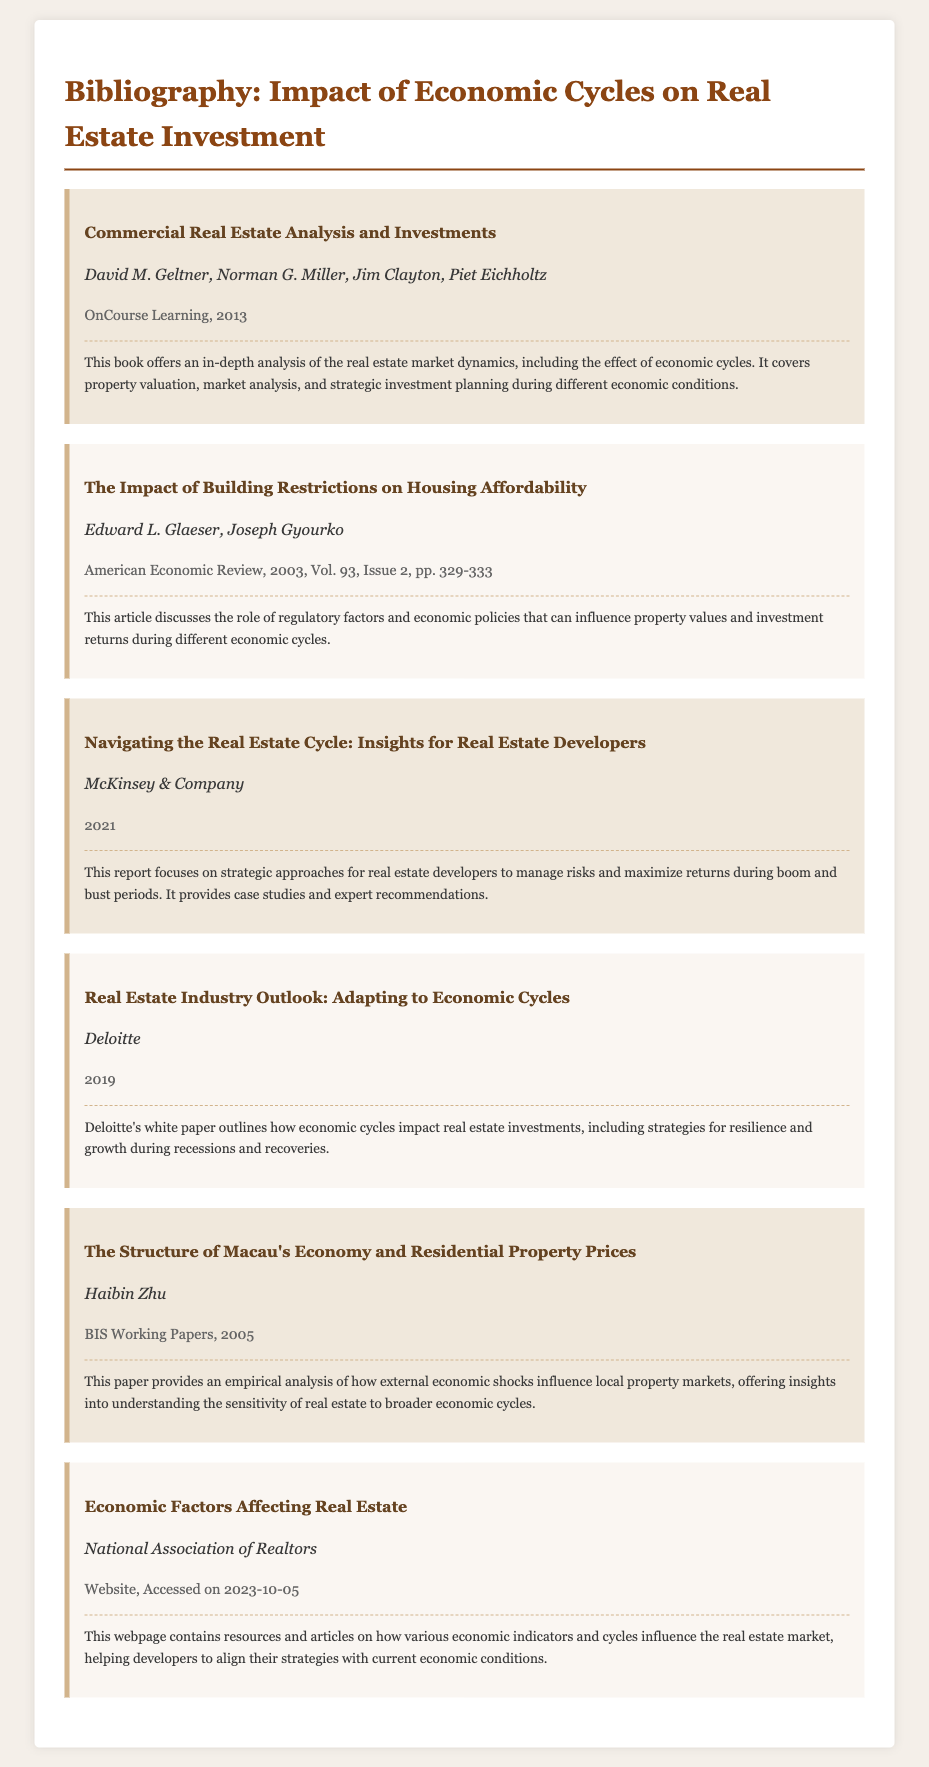what is the title of the first item in the bibliography? The title of the first item in the bibliography is found in the part of the document that lists the bibliographic entries.
Answer: Commercial Real Estate Analysis and Investments who are the authors of "Navigating the Real Estate Cycle: Insights for Real Estate Developers"? The authors of the specified report are listed right under the title in its respective section.
Answer: McKinsey & Company in which year was the article "The Impact of Building Restrictions on Housing Affordability" published? The publication year of this article can be found in the publication information section of the bibliography entry.
Answer: 2003 what type of document is "Economic Factors Affecting Real Estate"? The type of document for this entry is indicated in the publication information portion of the bibliography.
Answer: Website how many bibliographic items are listed in the document? The total number of bibliographic items is counted from each entry in the rendered document.
Answer: Six what is the main focus of Deloitte's white paper? The main focus can be summarized by looking at the description provided for this particular item in the bibliography.
Answer: Economic cycles impact real estate investments which organization produced the report "Navigating the Real Estate Cycle: Insights for Real Estate Developers"? The organization responsible for this report can be identified through the authorship details provided in the bibliography entry.
Answer: McKinsey & Company what is the publication year of the book "Commercial Real Estate Analysis and Investments"? The publication year is included in the publication information section of this bibliographic item.
Answer: 2013 